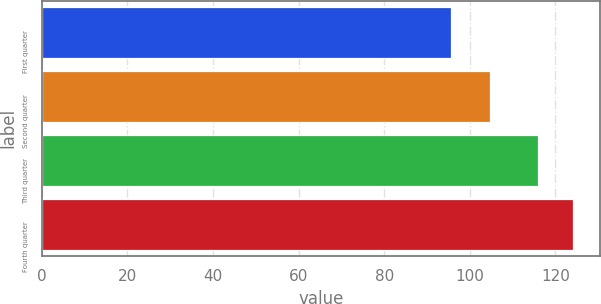<chart> <loc_0><loc_0><loc_500><loc_500><bar_chart><fcel>First quarter<fcel>Second quarter<fcel>Third quarter<fcel>Fourth quarter<nl><fcel>95.59<fcel>104.74<fcel>115.97<fcel>124.17<nl></chart> 